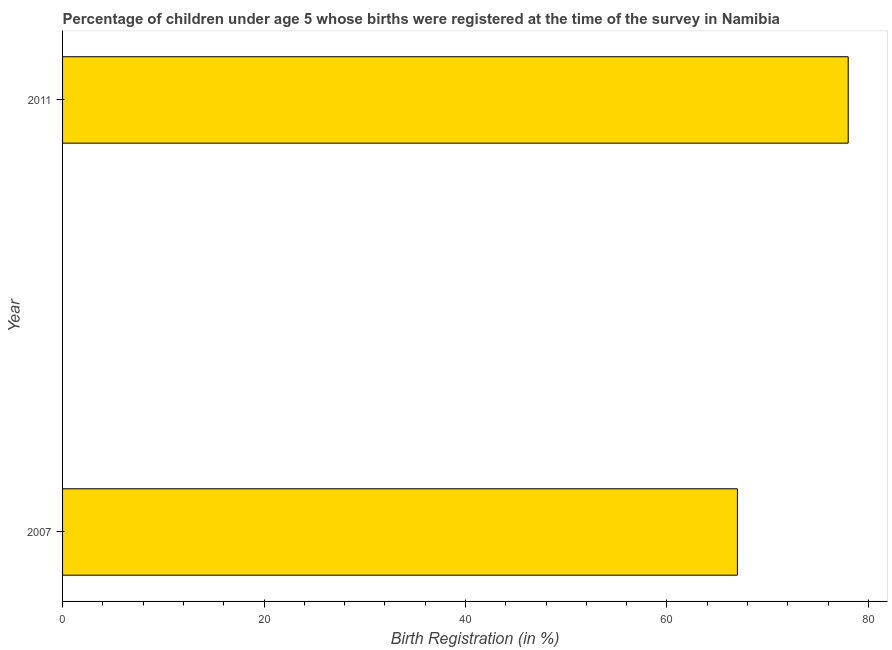Does the graph contain any zero values?
Your response must be concise. No. What is the title of the graph?
Offer a terse response. Percentage of children under age 5 whose births were registered at the time of the survey in Namibia. What is the label or title of the X-axis?
Provide a short and direct response. Birth Registration (in %). What is the label or title of the Y-axis?
Offer a very short reply. Year. What is the birth registration in 2007?
Your answer should be compact. 67. Across all years, what is the maximum birth registration?
Your answer should be very brief. 78. Across all years, what is the minimum birth registration?
Offer a terse response. 67. In which year was the birth registration minimum?
Make the answer very short. 2007. What is the sum of the birth registration?
Offer a very short reply. 145. What is the difference between the birth registration in 2007 and 2011?
Provide a short and direct response. -11. What is the median birth registration?
Provide a succinct answer. 72.5. In how many years, is the birth registration greater than 76 %?
Provide a short and direct response. 1. What is the ratio of the birth registration in 2007 to that in 2011?
Offer a terse response. 0.86. Is the birth registration in 2007 less than that in 2011?
Provide a short and direct response. Yes. In how many years, is the birth registration greater than the average birth registration taken over all years?
Your answer should be very brief. 1. How many bars are there?
Ensure brevity in your answer.  2. Are all the bars in the graph horizontal?
Give a very brief answer. Yes. How many years are there in the graph?
Your answer should be very brief. 2. Are the values on the major ticks of X-axis written in scientific E-notation?
Your response must be concise. No. What is the Birth Registration (in %) of 2007?
Make the answer very short. 67. What is the Birth Registration (in %) of 2011?
Ensure brevity in your answer.  78. What is the ratio of the Birth Registration (in %) in 2007 to that in 2011?
Ensure brevity in your answer.  0.86. 